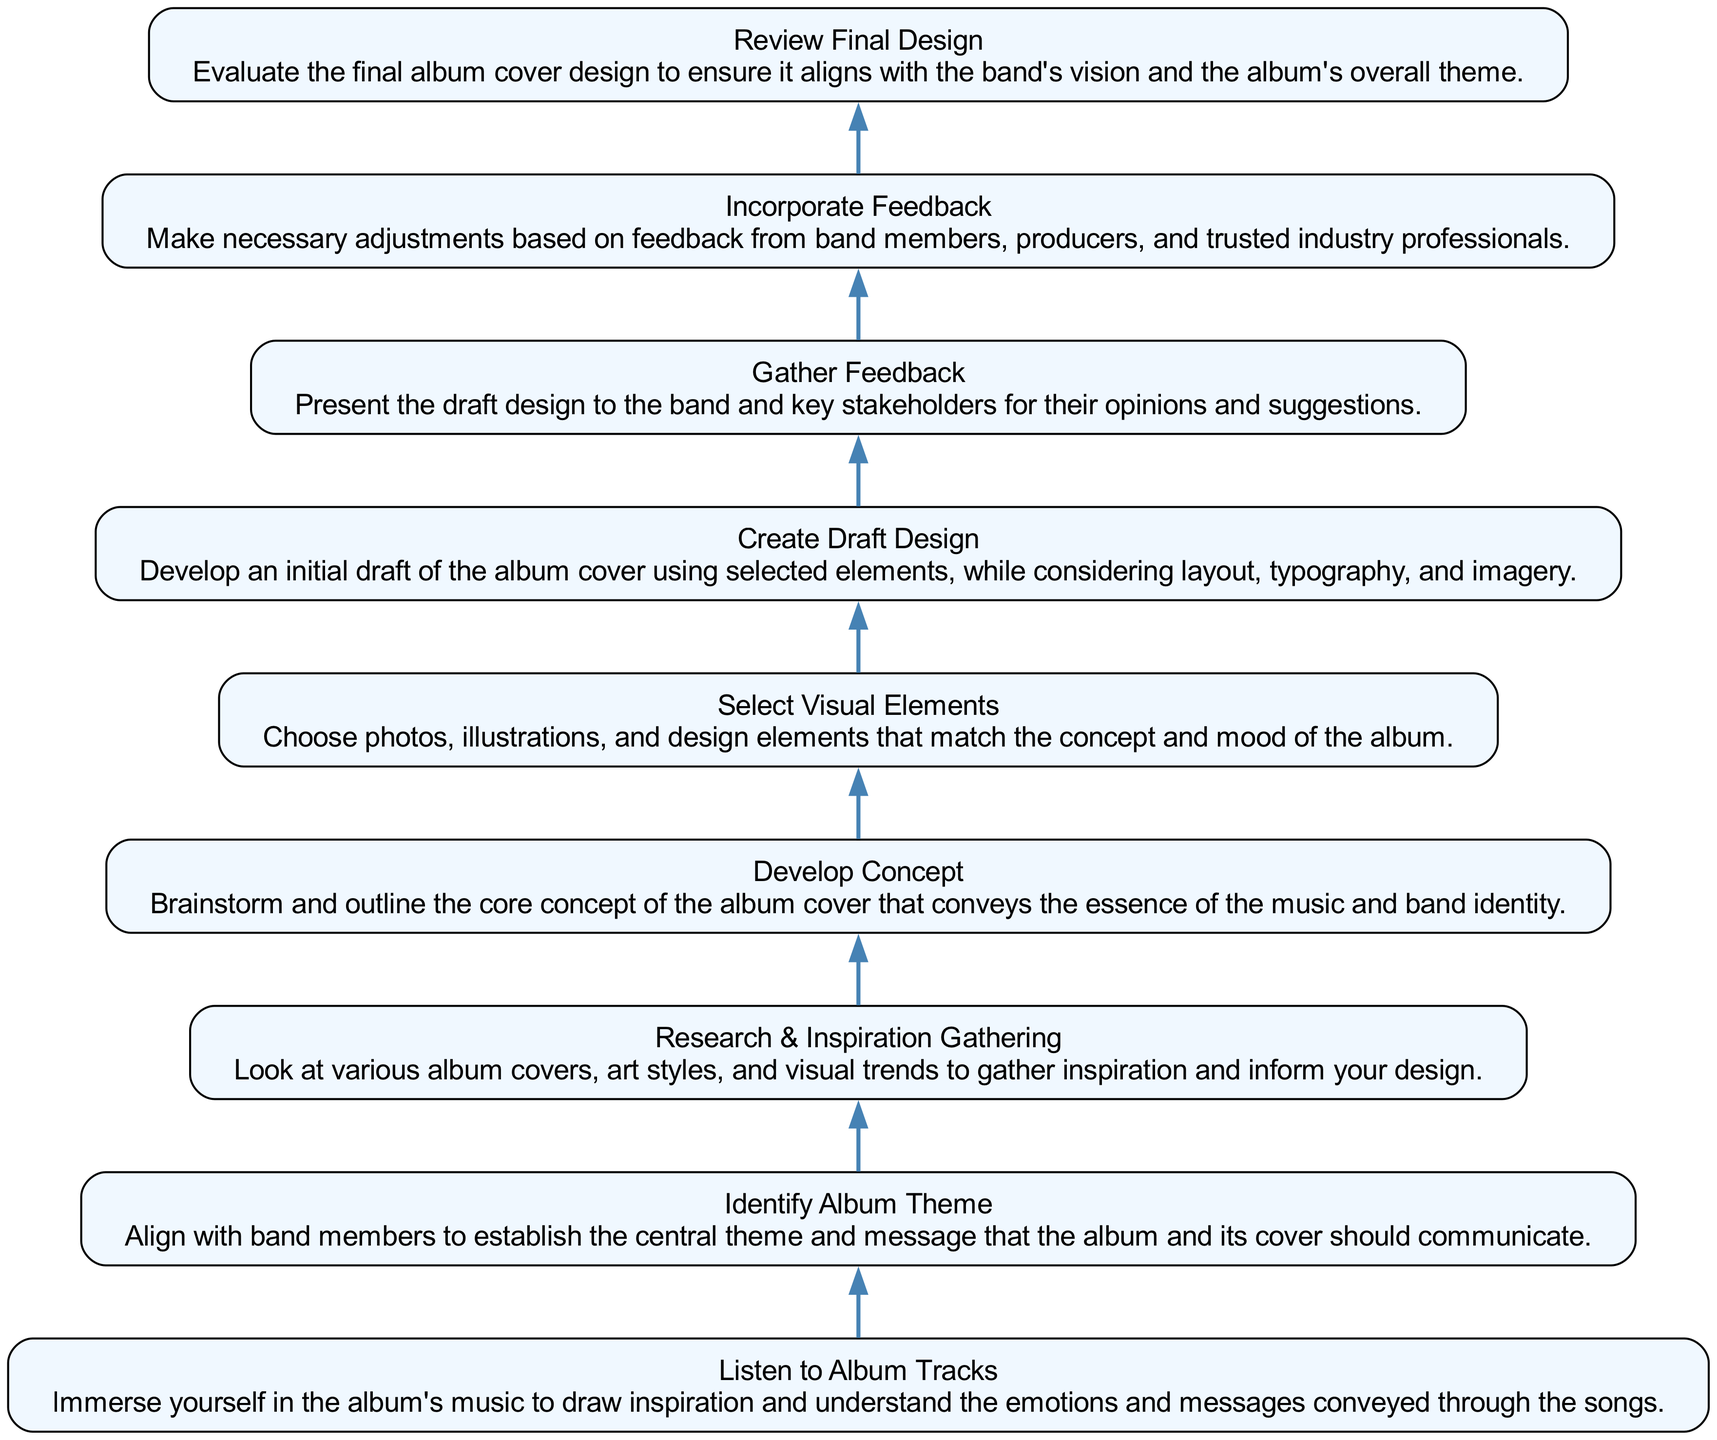What is the first step in the album cover development process? The first step is "Listen to Album Tracks." This can be found at the bottom of the flowchart as it initiates the process by providing inspiration from the music itself.
Answer: Listen to Album Tracks How many total steps are in the diagram? The diagram shows a total of 9 steps. By counting each individual step from the bottom to the top, we find there are 9 distinct nodes in the flowchart.
Answer: 9 What step comes immediately before "Gather Feedback"? The step that comes immediately before "Gather Feedback" is "Create Draft Design." This can be verified by identifying the sequential flow from the nodes.
Answer: Create Draft Design What visual elements do you select after developing the concept? After developing the concept, the next step is to "Select Visual Elements." This results from the flow that emphasizes selecting elements that correspond to the established concept.
Answer: Select Visual Elements What is the last step in the flowchart? The last step is "Review Final Design." It is located at the top of the diagram and signifies the final evaluation of the design process.
Answer: Review Final Design Which step includes gathering inspiration? The step that includes gathering inspiration is "Research & Inspiration Gathering." This step is crucial for informing the design decisions based on existing styles and trends.
Answer: Research & Inspiration Gathering How does feedback play a role in the process? Feedback is gathered in two steps: "Gather Feedback" and "Incorporate Feedback." This indicates that feedback is critical for refining and improving the draft design after initial input.
Answer: Gather Feedback and Incorporate Feedback Which step involves aligning with band members on the album's message? The step that involves aligning with band members on the album's message is "Identify Album Theme." This step highlights collaboration with band members to ensure the conceptual alignment of the album cover.
Answer: Identify Album Theme What is the connection between listening to album tracks and developing the concept? The connection is that "Listen to Album Tracks" feeds into "Develop Concept." By immersing in the music, the designer gains insights that help outline the core concept of the album cover.
Answer: Listen to Album Tracks and Develop Concept 